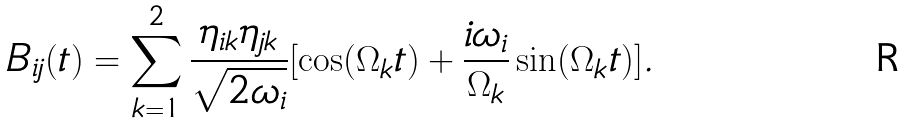<formula> <loc_0><loc_0><loc_500><loc_500>B _ { i j } ( t ) = \sum _ { k = 1 } ^ { 2 } \frac { \eta _ { i k } \eta _ { j k } } { \sqrt { 2 \omega _ { i } } } [ \cos ( \Omega _ { k } t ) + \frac { i \omega _ { i } } { \Omega _ { k } } \sin ( \Omega _ { k } t ) ] .</formula> 